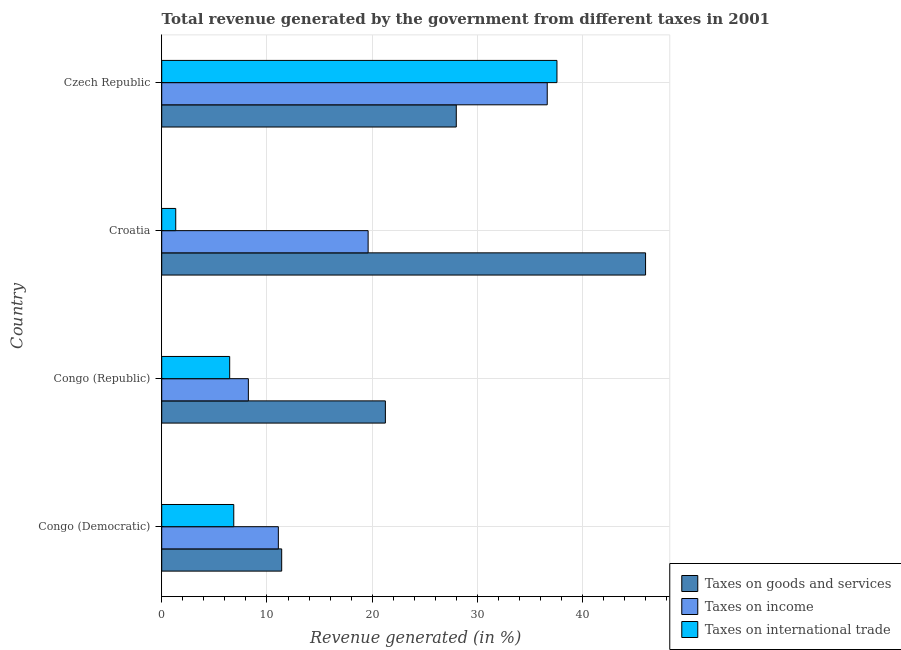Are the number of bars on each tick of the Y-axis equal?
Your answer should be compact. Yes. How many bars are there on the 3rd tick from the bottom?
Offer a very short reply. 3. What is the label of the 3rd group of bars from the top?
Offer a very short reply. Congo (Republic). What is the percentage of revenue generated by taxes on income in Czech Republic?
Offer a terse response. 36.63. Across all countries, what is the maximum percentage of revenue generated by tax on international trade?
Offer a terse response. 37.55. Across all countries, what is the minimum percentage of revenue generated by tax on international trade?
Your response must be concise. 1.33. In which country was the percentage of revenue generated by taxes on goods and services maximum?
Your response must be concise. Croatia. In which country was the percentage of revenue generated by taxes on income minimum?
Offer a terse response. Congo (Republic). What is the total percentage of revenue generated by taxes on goods and services in the graph?
Offer a very short reply. 106.62. What is the difference between the percentage of revenue generated by taxes on goods and services in Croatia and that in Czech Republic?
Offer a very short reply. 17.99. What is the difference between the percentage of revenue generated by tax on international trade in Croatia and the percentage of revenue generated by taxes on goods and services in Congo (Republic)?
Ensure brevity in your answer.  -19.92. What is the average percentage of revenue generated by taxes on goods and services per country?
Give a very brief answer. 26.65. What is the difference between the percentage of revenue generated by taxes on income and percentage of revenue generated by taxes on goods and services in Czech Republic?
Offer a terse response. 8.64. In how many countries, is the percentage of revenue generated by taxes on income greater than 8 %?
Offer a very short reply. 4. What is the ratio of the percentage of revenue generated by taxes on goods and services in Congo (Democratic) to that in Czech Republic?
Provide a succinct answer. 0.41. Is the percentage of revenue generated by tax on international trade in Congo (Democratic) less than that in Congo (Republic)?
Offer a terse response. No. Is the difference between the percentage of revenue generated by taxes on income in Congo (Democratic) and Czech Republic greater than the difference between the percentage of revenue generated by tax on international trade in Congo (Democratic) and Czech Republic?
Give a very brief answer. Yes. What is the difference between the highest and the second highest percentage of revenue generated by taxes on income?
Offer a terse response. 17.02. What is the difference between the highest and the lowest percentage of revenue generated by taxes on income?
Give a very brief answer. 28.4. What does the 1st bar from the top in Czech Republic represents?
Offer a terse response. Taxes on international trade. What does the 3rd bar from the bottom in Czech Republic represents?
Give a very brief answer. Taxes on international trade. Is it the case that in every country, the sum of the percentage of revenue generated by taxes on goods and services and percentage of revenue generated by taxes on income is greater than the percentage of revenue generated by tax on international trade?
Your response must be concise. Yes. How many countries are there in the graph?
Ensure brevity in your answer.  4. What is the difference between two consecutive major ticks on the X-axis?
Ensure brevity in your answer.  10. Are the values on the major ticks of X-axis written in scientific E-notation?
Your response must be concise. No. Does the graph contain any zero values?
Offer a very short reply. No. Does the graph contain grids?
Provide a short and direct response. Yes. What is the title of the graph?
Offer a very short reply. Total revenue generated by the government from different taxes in 2001. Does "Poland" appear as one of the legend labels in the graph?
Make the answer very short. No. What is the label or title of the X-axis?
Your answer should be very brief. Revenue generated (in %). What is the label or title of the Y-axis?
Make the answer very short. Country. What is the Revenue generated (in %) of Taxes on goods and services in Congo (Democratic)?
Ensure brevity in your answer.  11.4. What is the Revenue generated (in %) in Taxes on income in Congo (Democratic)?
Keep it short and to the point. 11.08. What is the Revenue generated (in %) of Taxes on international trade in Congo (Democratic)?
Provide a succinct answer. 6.85. What is the Revenue generated (in %) of Taxes on goods and services in Congo (Republic)?
Your answer should be very brief. 21.25. What is the Revenue generated (in %) of Taxes on income in Congo (Republic)?
Offer a very short reply. 8.23. What is the Revenue generated (in %) of Taxes on international trade in Congo (Republic)?
Keep it short and to the point. 6.46. What is the Revenue generated (in %) of Taxes on goods and services in Croatia?
Ensure brevity in your answer.  45.97. What is the Revenue generated (in %) of Taxes on income in Croatia?
Make the answer very short. 19.61. What is the Revenue generated (in %) in Taxes on international trade in Croatia?
Ensure brevity in your answer.  1.33. What is the Revenue generated (in %) of Taxes on goods and services in Czech Republic?
Keep it short and to the point. 27.99. What is the Revenue generated (in %) in Taxes on income in Czech Republic?
Offer a very short reply. 36.63. What is the Revenue generated (in %) of Taxes on international trade in Czech Republic?
Provide a succinct answer. 37.55. Across all countries, what is the maximum Revenue generated (in %) of Taxes on goods and services?
Keep it short and to the point. 45.97. Across all countries, what is the maximum Revenue generated (in %) of Taxes on income?
Offer a very short reply. 36.63. Across all countries, what is the maximum Revenue generated (in %) of Taxes on international trade?
Provide a short and direct response. 37.55. Across all countries, what is the minimum Revenue generated (in %) of Taxes on goods and services?
Your answer should be very brief. 11.4. Across all countries, what is the minimum Revenue generated (in %) of Taxes on income?
Provide a succinct answer. 8.23. Across all countries, what is the minimum Revenue generated (in %) in Taxes on international trade?
Keep it short and to the point. 1.33. What is the total Revenue generated (in %) in Taxes on goods and services in the graph?
Your answer should be compact. 106.62. What is the total Revenue generated (in %) in Taxes on income in the graph?
Provide a succinct answer. 75.56. What is the total Revenue generated (in %) in Taxes on international trade in the graph?
Your answer should be very brief. 52.19. What is the difference between the Revenue generated (in %) in Taxes on goods and services in Congo (Democratic) and that in Congo (Republic)?
Provide a short and direct response. -9.85. What is the difference between the Revenue generated (in %) in Taxes on income in Congo (Democratic) and that in Congo (Republic)?
Your answer should be compact. 2.85. What is the difference between the Revenue generated (in %) of Taxes on international trade in Congo (Democratic) and that in Congo (Republic)?
Your answer should be compact. 0.39. What is the difference between the Revenue generated (in %) of Taxes on goods and services in Congo (Democratic) and that in Croatia?
Give a very brief answer. -34.57. What is the difference between the Revenue generated (in %) in Taxes on income in Congo (Democratic) and that in Croatia?
Offer a very short reply. -8.53. What is the difference between the Revenue generated (in %) in Taxes on international trade in Congo (Democratic) and that in Croatia?
Provide a succinct answer. 5.51. What is the difference between the Revenue generated (in %) in Taxes on goods and services in Congo (Democratic) and that in Czech Republic?
Offer a terse response. -16.59. What is the difference between the Revenue generated (in %) of Taxes on income in Congo (Democratic) and that in Czech Republic?
Your response must be concise. -25.55. What is the difference between the Revenue generated (in %) of Taxes on international trade in Congo (Democratic) and that in Czech Republic?
Provide a short and direct response. -30.71. What is the difference between the Revenue generated (in %) of Taxes on goods and services in Congo (Republic) and that in Croatia?
Your response must be concise. -24.72. What is the difference between the Revenue generated (in %) in Taxes on income in Congo (Republic) and that in Croatia?
Offer a very short reply. -11.38. What is the difference between the Revenue generated (in %) of Taxes on international trade in Congo (Republic) and that in Croatia?
Provide a short and direct response. 5.13. What is the difference between the Revenue generated (in %) in Taxes on goods and services in Congo (Republic) and that in Czech Republic?
Provide a succinct answer. -6.74. What is the difference between the Revenue generated (in %) of Taxes on income in Congo (Republic) and that in Czech Republic?
Make the answer very short. -28.4. What is the difference between the Revenue generated (in %) of Taxes on international trade in Congo (Republic) and that in Czech Republic?
Your answer should be compact. -31.1. What is the difference between the Revenue generated (in %) of Taxes on goods and services in Croatia and that in Czech Republic?
Your answer should be compact. 17.99. What is the difference between the Revenue generated (in %) in Taxes on income in Croatia and that in Czech Republic?
Provide a short and direct response. -17.02. What is the difference between the Revenue generated (in %) of Taxes on international trade in Croatia and that in Czech Republic?
Your answer should be compact. -36.22. What is the difference between the Revenue generated (in %) of Taxes on goods and services in Congo (Democratic) and the Revenue generated (in %) of Taxes on income in Congo (Republic)?
Your answer should be very brief. 3.17. What is the difference between the Revenue generated (in %) in Taxes on goods and services in Congo (Democratic) and the Revenue generated (in %) in Taxes on international trade in Congo (Republic)?
Provide a short and direct response. 4.94. What is the difference between the Revenue generated (in %) of Taxes on income in Congo (Democratic) and the Revenue generated (in %) of Taxes on international trade in Congo (Republic)?
Give a very brief answer. 4.62. What is the difference between the Revenue generated (in %) of Taxes on goods and services in Congo (Democratic) and the Revenue generated (in %) of Taxes on income in Croatia?
Your answer should be very brief. -8.21. What is the difference between the Revenue generated (in %) of Taxes on goods and services in Congo (Democratic) and the Revenue generated (in %) of Taxes on international trade in Croatia?
Your answer should be very brief. 10.07. What is the difference between the Revenue generated (in %) of Taxes on income in Congo (Democratic) and the Revenue generated (in %) of Taxes on international trade in Croatia?
Provide a short and direct response. 9.75. What is the difference between the Revenue generated (in %) in Taxes on goods and services in Congo (Democratic) and the Revenue generated (in %) in Taxes on income in Czech Republic?
Offer a very short reply. -25.23. What is the difference between the Revenue generated (in %) of Taxes on goods and services in Congo (Democratic) and the Revenue generated (in %) of Taxes on international trade in Czech Republic?
Your answer should be compact. -26.15. What is the difference between the Revenue generated (in %) in Taxes on income in Congo (Democratic) and the Revenue generated (in %) in Taxes on international trade in Czech Republic?
Offer a terse response. -26.47. What is the difference between the Revenue generated (in %) in Taxes on goods and services in Congo (Republic) and the Revenue generated (in %) in Taxes on income in Croatia?
Give a very brief answer. 1.64. What is the difference between the Revenue generated (in %) in Taxes on goods and services in Congo (Republic) and the Revenue generated (in %) in Taxes on international trade in Croatia?
Keep it short and to the point. 19.92. What is the difference between the Revenue generated (in %) of Taxes on income in Congo (Republic) and the Revenue generated (in %) of Taxes on international trade in Croatia?
Your response must be concise. 6.9. What is the difference between the Revenue generated (in %) of Taxes on goods and services in Congo (Republic) and the Revenue generated (in %) of Taxes on income in Czech Republic?
Keep it short and to the point. -15.38. What is the difference between the Revenue generated (in %) in Taxes on goods and services in Congo (Republic) and the Revenue generated (in %) in Taxes on international trade in Czech Republic?
Provide a short and direct response. -16.3. What is the difference between the Revenue generated (in %) in Taxes on income in Congo (Republic) and the Revenue generated (in %) in Taxes on international trade in Czech Republic?
Your answer should be compact. -29.32. What is the difference between the Revenue generated (in %) in Taxes on goods and services in Croatia and the Revenue generated (in %) in Taxes on income in Czech Republic?
Ensure brevity in your answer.  9.34. What is the difference between the Revenue generated (in %) in Taxes on goods and services in Croatia and the Revenue generated (in %) in Taxes on international trade in Czech Republic?
Keep it short and to the point. 8.42. What is the difference between the Revenue generated (in %) in Taxes on income in Croatia and the Revenue generated (in %) in Taxes on international trade in Czech Republic?
Your response must be concise. -17.94. What is the average Revenue generated (in %) in Taxes on goods and services per country?
Make the answer very short. 26.65. What is the average Revenue generated (in %) in Taxes on income per country?
Keep it short and to the point. 18.89. What is the average Revenue generated (in %) in Taxes on international trade per country?
Keep it short and to the point. 13.05. What is the difference between the Revenue generated (in %) in Taxes on goods and services and Revenue generated (in %) in Taxes on income in Congo (Democratic)?
Your response must be concise. 0.32. What is the difference between the Revenue generated (in %) in Taxes on goods and services and Revenue generated (in %) in Taxes on international trade in Congo (Democratic)?
Your answer should be compact. 4.55. What is the difference between the Revenue generated (in %) in Taxes on income and Revenue generated (in %) in Taxes on international trade in Congo (Democratic)?
Make the answer very short. 4.24. What is the difference between the Revenue generated (in %) in Taxes on goods and services and Revenue generated (in %) in Taxes on income in Congo (Republic)?
Your answer should be very brief. 13.02. What is the difference between the Revenue generated (in %) of Taxes on goods and services and Revenue generated (in %) of Taxes on international trade in Congo (Republic)?
Make the answer very short. 14.79. What is the difference between the Revenue generated (in %) in Taxes on income and Revenue generated (in %) in Taxes on international trade in Congo (Republic)?
Your answer should be very brief. 1.77. What is the difference between the Revenue generated (in %) of Taxes on goods and services and Revenue generated (in %) of Taxes on income in Croatia?
Offer a very short reply. 26.36. What is the difference between the Revenue generated (in %) of Taxes on goods and services and Revenue generated (in %) of Taxes on international trade in Croatia?
Your answer should be compact. 44.64. What is the difference between the Revenue generated (in %) in Taxes on income and Revenue generated (in %) in Taxes on international trade in Croatia?
Provide a short and direct response. 18.28. What is the difference between the Revenue generated (in %) of Taxes on goods and services and Revenue generated (in %) of Taxes on income in Czech Republic?
Your answer should be compact. -8.64. What is the difference between the Revenue generated (in %) in Taxes on goods and services and Revenue generated (in %) in Taxes on international trade in Czech Republic?
Your answer should be compact. -9.57. What is the difference between the Revenue generated (in %) in Taxes on income and Revenue generated (in %) in Taxes on international trade in Czech Republic?
Offer a very short reply. -0.92. What is the ratio of the Revenue generated (in %) of Taxes on goods and services in Congo (Democratic) to that in Congo (Republic)?
Your answer should be compact. 0.54. What is the ratio of the Revenue generated (in %) of Taxes on income in Congo (Democratic) to that in Congo (Republic)?
Keep it short and to the point. 1.35. What is the ratio of the Revenue generated (in %) of Taxes on international trade in Congo (Democratic) to that in Congo (Republic)?
Your answer should be very brief. 1.06. What is the ratio of the Revenue generated (in %) in Taxes on goods and services in Congo (Democratic) to that in Croatia?
Give a very brief answer. 0.25. What is the ratio of the Revenue generated (in %) of Taxes on income in Congo (Democratic) to that in Croatia?
Keep it short and to the point. 0.56. What is the ratio of the Revenue generated (in %) in Taxes on international trade in Congo (Democratic) to that in Croatia?
Offer a terse response. 5.14. What is the ratio of the Revenue generated (in %) of Taxes on goods and services in Congo (Democratic) to that in Czech Republic?
Your answer should be very brief. 0.41. What is the ratio of the Revenue generated (in %) of Taxes on income in Congo (Democratic) to that in Czech Republic?
Make the answer very short. 0.3. What is the ratio of the Revenue generated (in %) in Taxes on international trade in Congo (Democratic) to that in Czech Republic?
Offer a very short reply. 0.18. What is the ratio of the Revenue generated (in %) of Taxes on goods and services in Congo (Republic) to that in Croatia?
Offer a terse response. 0.46. What is the ratio of the Revenue generated (in %) in Taxes on income in Congo (Republic) to that in Croatia?
Provide a succinct answer. 0.42. What is the ratio of the Revenue generated (in %) of Taxes on international trade in Congo (Republic) to that in Croatia?
Ensure brevity in your answer.  4.85. What is the ratio of the Revenue generated (in %) in Taxes on goods and services in Congo (Republic) to that in Czech Republic?
Give a very brief answer. 0.76. What is the ratio of the Revenue generated (in %) of Taxes on income in Congo (Republic) to that in Czech Republic?
Your response must be concise. 0.22. What is the ratio of the Revenue generated (in %) of Taxes on international trade in Congo (Republic) to that in Czech Republic?
Ensure brevity in your answer.  0.17. What is the ratio of the Revenue generated (in %) in Taxes on goods and services in Croatia to that in Czech Republic?
Keep it short and to the point. 1.64. What is the ratio of the Revenue generated (in %) in Taxes on income in Croatia to that in Czech Republic?
Provide a short and direct response. 0.54. What is the ratio of the Revenue generated (in %) of Taxes on international trade in Croatia to that in Czech Republic?
Make the answer very short. 0.04. What is the difference between the highest and the second highest Revenue generated (in %) of Taxes on goods and services?
Your response must be concise. 17.99. What is the difference between the highest and the second highest Revenue generated (in %) in Taxes on income?
Ensure brevity in your answer.  17.02. What is the difference between the highest and the second highest Revenue generated (in %) in Taxes on international trade?
Offer a very short reply. 30.71. What is the difference between the highest and the lowest Revenue generated (in %) in Taxes on goods and services?
Offer a very short reply. 34.57. What is the difference between the highest and the lowest Revenue generated (in %) of Taxes on income?
Provide a succinct answer. 28.4. What is the difference between the highest and the lowest Revenue generated (in %) of Taxes on international trade?
Your answer should be very brief. 36.22. 